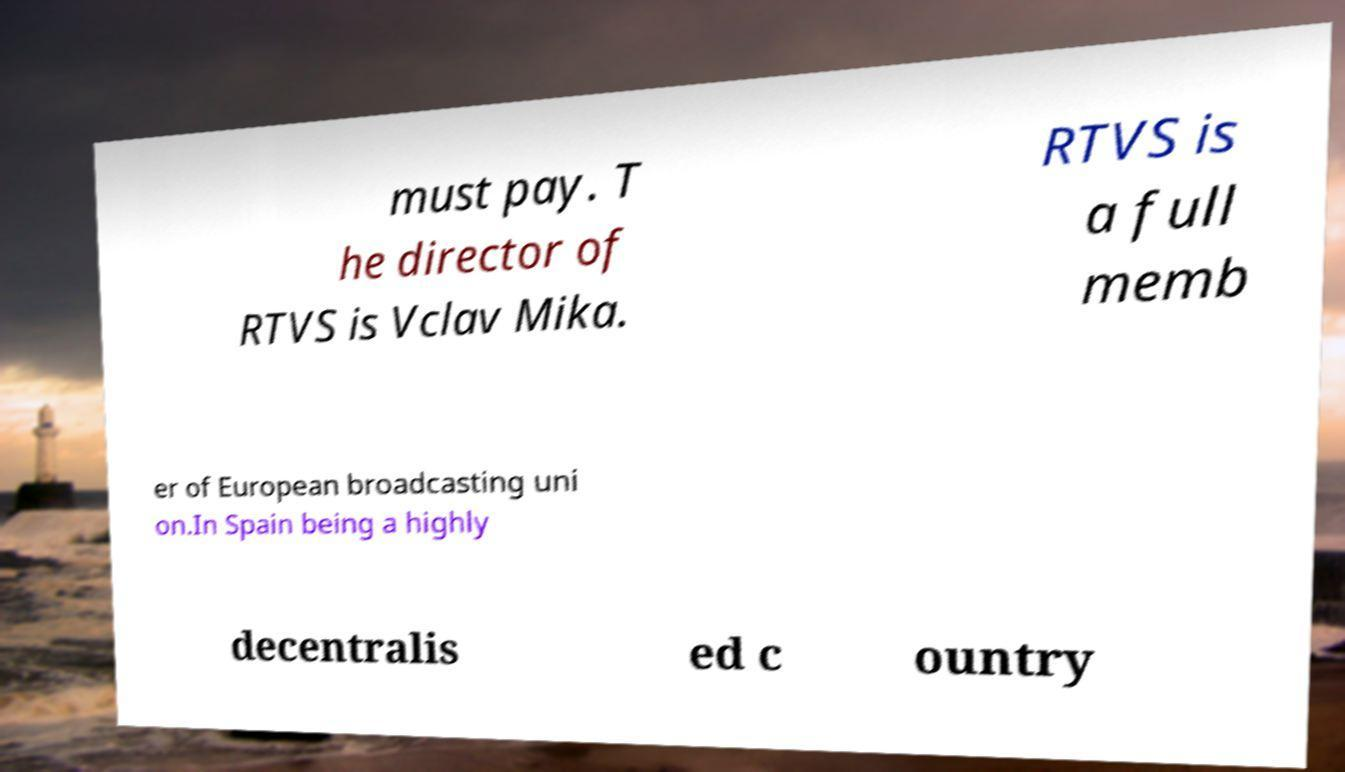What messages or text are displayed in this image? I need them in a readable, typed format. must pay. T he director of RTVS is Vclav Mika. RTVS is a full memb er of European broadcasting uni on.In Spain being a highly decentralis ed c ountry 